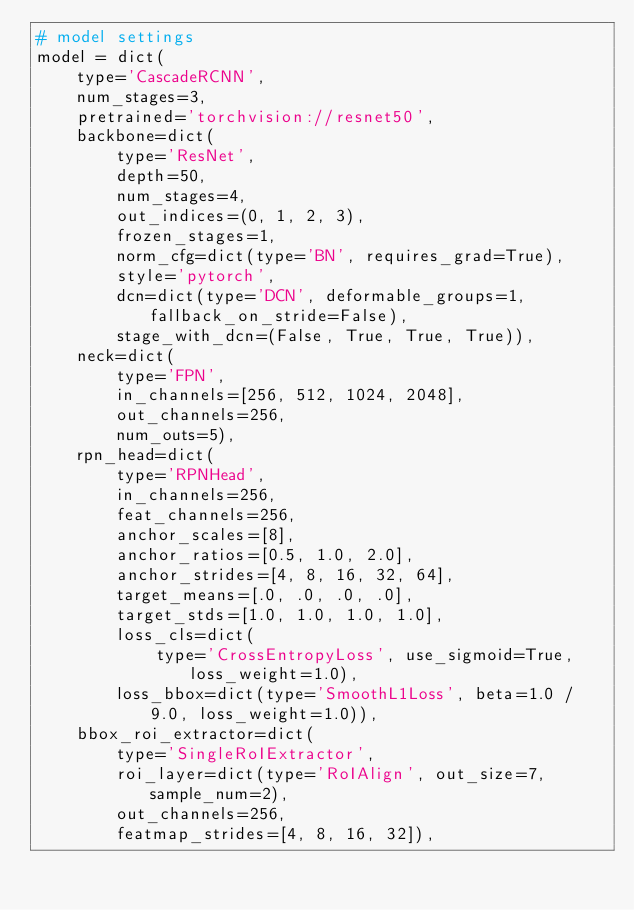<code> <loc_0><loc_0><loc_500><loc_500><_Python_># model settings
model = dict(
    type='CascadeRCNN',
    num_stages=3,
    pretrained='torchvision://resnet50',
    backbone=dict(
        type='ResNet',
        depth=50,
        num_stages=4,
        out_indices=(0, 1, 2, 3),
        frozen_stages=1,
        norm_cfg=dict(type='BN', requires_grad=True),
        style='pytorch',
        dcn=dict(type='DCN', deformable_groups=1, fallback_on_stride=False),
        stage_with_dcn=(False, True, True, True)),
    neck=dict(
        type='FPN',
        in_channels=[256, 512, 1024, 2048],
        out_channels=256,
        num_outs=5),
    rpn_head=dict(
        type='RPNHead',
        in_channels=256,
        feat_channels=256,
        anchor_scales=[8],
        anchor_ratios=[0.5, 1.0, 2.0],
        anchor_strides=[4, 8, 16, 32, 64],
        target_means=[.0, .0, .0, .0],
        target_stds=[1.0, 1.0, 1.0, 1.0],
        loss_cls=dict(
            type='CrossEntropyLoss', use_sigmoid=True, loss_weight=1.0),
        loss_bbox=dict(type='SmoothL1Loss', beta=1.0 / 9.0, loss_weight=1.0)),
    bbox_roi_extractor=dict(
        type='SingleRoIExtractor',
        roi_layer=dict(type='RoIAlign', out_size=7, sample_num=2),
        out_channels=256,
        featmap_strides=[4, 8, 16, 32]),</code> 